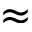Convert formula to latex. <formula><loc_0><loc_0><loc_500><loc_500>\approx</formula> 